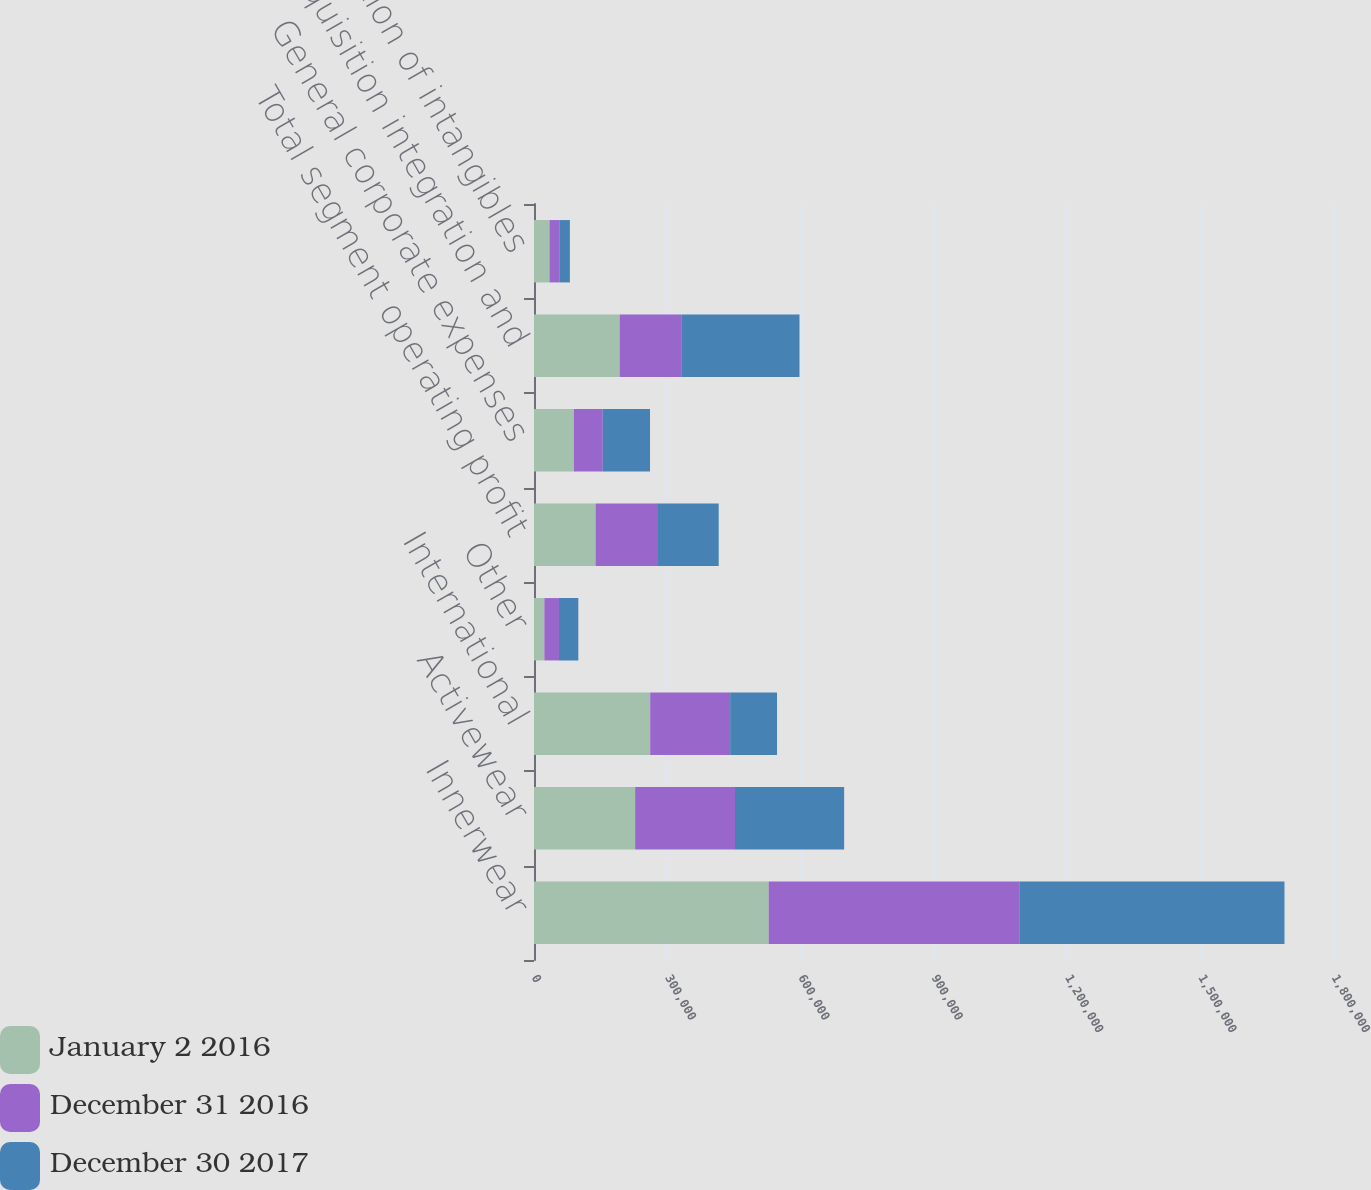Convert chart. <chart><loc_0><loc_0><loc_500><loc_500><stacked_bar_chart><ecel><fcel>Innerwear<fcel>Activewear<fcel>International<fcel>Other<fcel>Total segment operating profit<fcel>General corporate expenses<fcel>Acquisition integration and<fcel>Amortization of intangibles<nl><fcel>January 2 2016<fcel>528038<fcel>227589<fcel>261411<fcel>23364<fcel>138519<fcel>89690<fcel>192752<fcel>34892<nl><fcel>December 31 2016<fcel>563905<fcel>224658<fcel>179917<fcel>32801<fcel>138519<fcel>64995<fcel>138519<fcel>22118<nl><fcel>December 30 2017<fcel>596634<fcel>245563<fcel>105515<fcel>43582<fcel>138519<fcel>106379<fcel>266060<fcel>23737<nl></chart> 